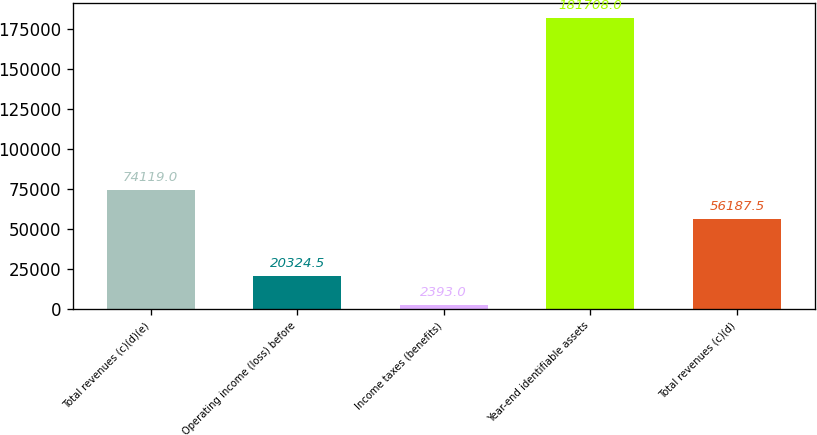<chart> <loc_0><loc_0><loc_500><loc_500><bar_chart><fcel>Total revenues (c)(d)(e)<fcel>Operating income (loss) before<fcel>Income taxes (benefits)<fcel>Year-end identifiable assets<fcel>Total revenues (c)(d)<nl><fcel>74119<fcel>20324.5<fcel>2393<fcel>181708<fcel>56187.5<nl></chart> 